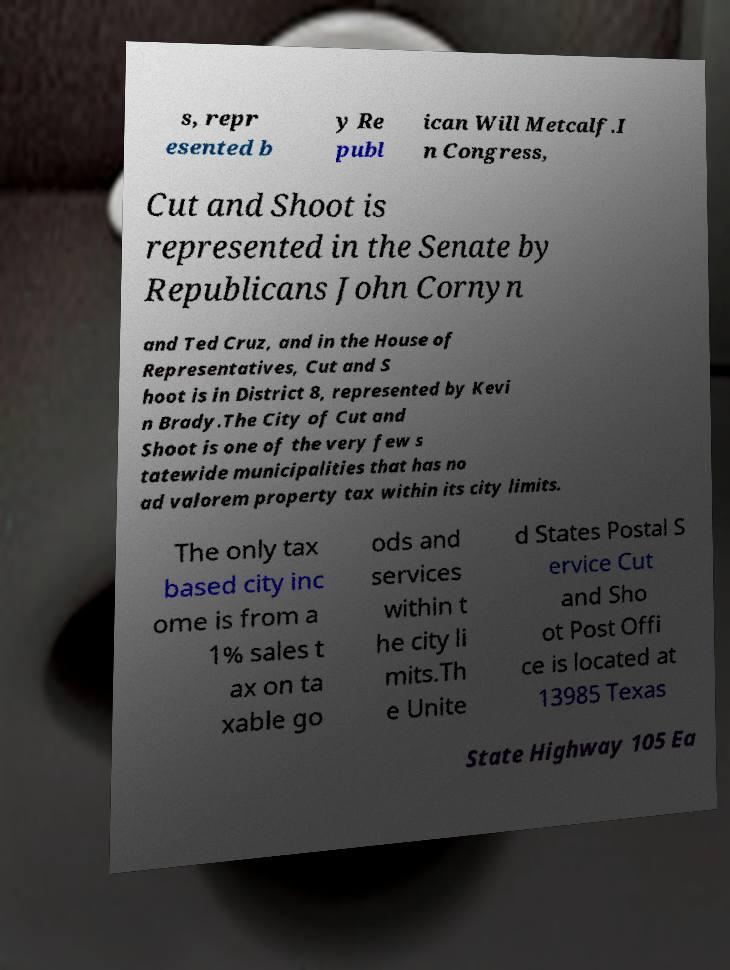Could you extract and type out the text from this image? s, repr esented b y Re publ ican Will Metcalf.I n Congress, Cut and Shoot is represented in the Senate by Republicans John Cornyn and Ted Cruz, and in the House of Representatives, Cut and S hoot is in District 8, represented by Kevi n Brady.The City of Cut and Shoot is one of the very few s tatewide municipalities that has no ad valorem property tax within its city limits. The only tax based city inc ome is from a 1% sales t ax on ta xable go ods and services within t he city li mits.Th e Unite d States Postal S ervice Cut and Sho ot Post Offi ce is located at 13985 Texas State Highway 105 Ea 